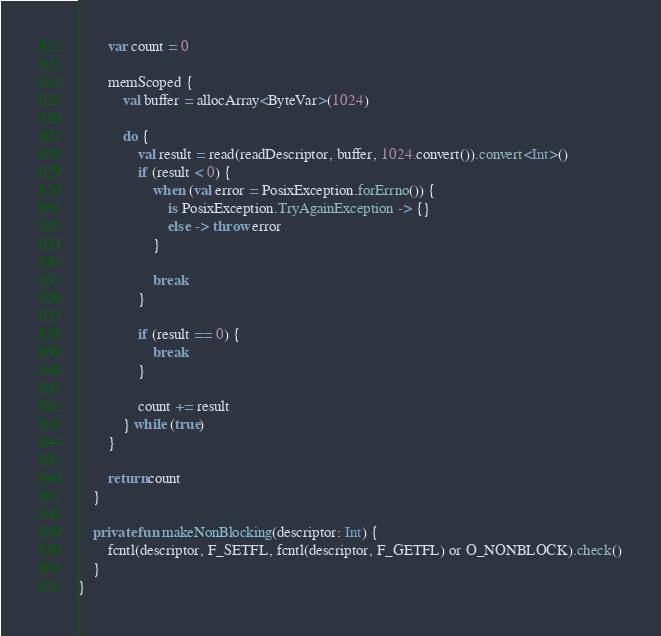<code> <loc_0><loc_0><loc_500><loc_500><_Kotlin_>        var count = 0

        memScoped {
            val buffer = allocArray<ByteVar>(1024)

            do {
                val result = read(readDescriptor, buffer, 1024.convert()).convert<Int>()
                if (result < 0) {
                    when (val error = PosixException.forErrno()) {
                        is PosixException.TryAgainException -> {}
                        else -> throw error
                    }

                    break
                }

                if (result == 0) {
                    break
                }

                count += result
            } while (true)
        }

        return count
    }

    private fun makeNonBlocking(descriptor: Int) {
        fcntl(descriptor, F_SETFL, fcntl(descriptor, F_GETFL) or O_NONBLOCK).check()
    }
}
</code> 